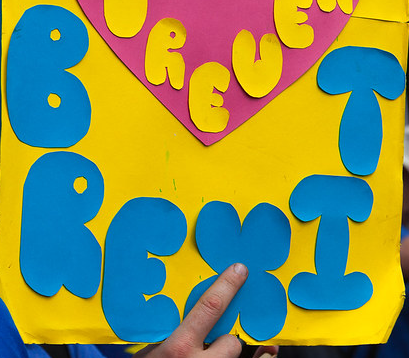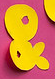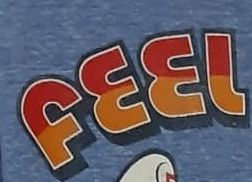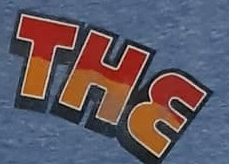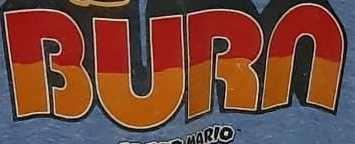Read the text from these images in sequence, separated by a semicolon. BREXIT; &; FEEL; THE; BURN 